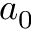<formula> <loc_0><loc_0><loc_500><loc_500>a _ { 0 }</formula> 